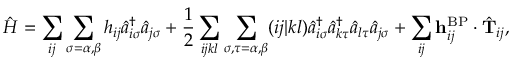<formula> <loc_0><loc_0><loc_500><loc_500>\hat { H } = \sum _ { i j } \sum _ { \sigma = \alpha , \beta } h _ { i j } \hat { a } _ { i \sigma } ^ { \dagger } \hat { a } _ { j \sigma } + \frac { 1 } { 2 } \sum _ { i j k l } \sum _ { \sigma , \tau = \alpha , \beta } ( i j | k l ) \hat { a } _ { i \sigma } ^ { \dagger } \hat { a } _ { k \tau } ^ { \dagger } \hat { a } _ { l \tau } \hat { a } _ { j \sigma } + \sum _ { i j } h _ { i j } ^ { B P } \cdot \hat { T } _ { i j } ,</formula> 